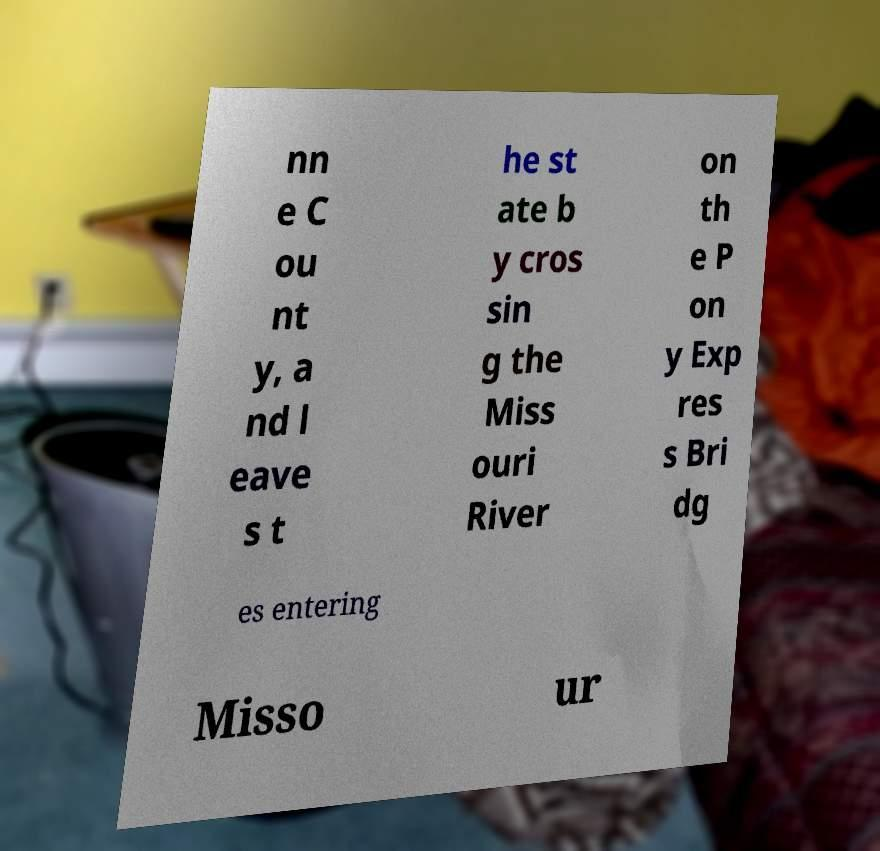Please read and relay the text visible in this image. What does it say? nn e C ou nt y, a nd l eave s t he st ate b y cros sin g the Miss ouri River on th e P on y Exp res s Bri dg es entering Misso ur 